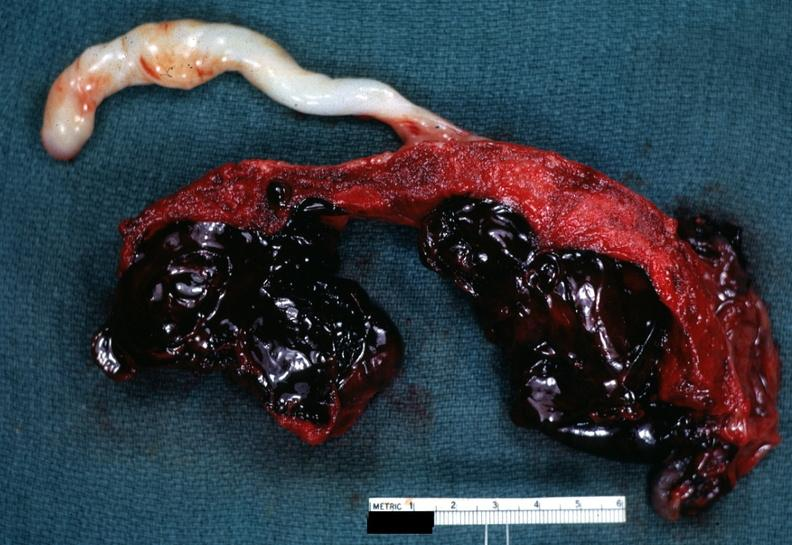what is present?
Answer the question using a single word or phrase. Placenta 